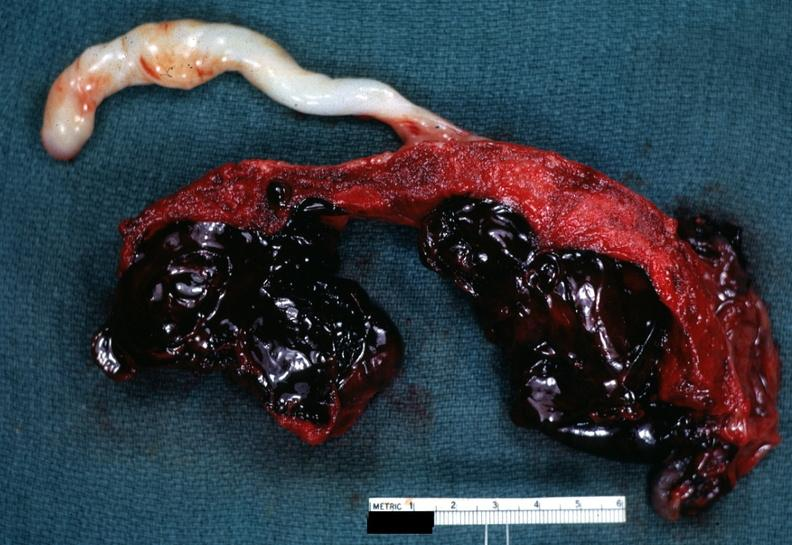what is present?
Answer the question using a single word or phrase. Placenta 